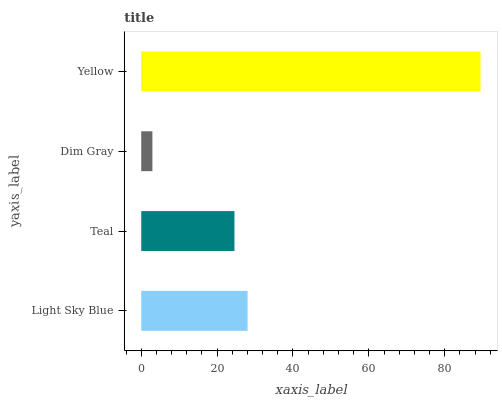Is Dim Gray the minimum?
Answer yes or no. Yes. Is Yellow the maximum?
Answer yes or no. Yes. Is Teal the minimum?
Answer yes or no. No. Is Teal the maximum?
Answer yes or no. No. Is Light Sky Blue greater than Teal?
Answer yes or no. Yes. Is Teal less than Light Sky Blue?
Answer yes or no. Yes. Is Teal greater than Light Sky Blue?
Answer yes or no. No. Is Light Sky Blue less than Teal?
Answer yes or no. No. Is Light Sky Blue the high median?
Answer yes or no. Yes. Is Teal the low median?
Answer yes or no. Yes. Is Yellow the high median?
Answer yes or no. No. Is Dim Gray the low median?
Answer yes or no. No. 